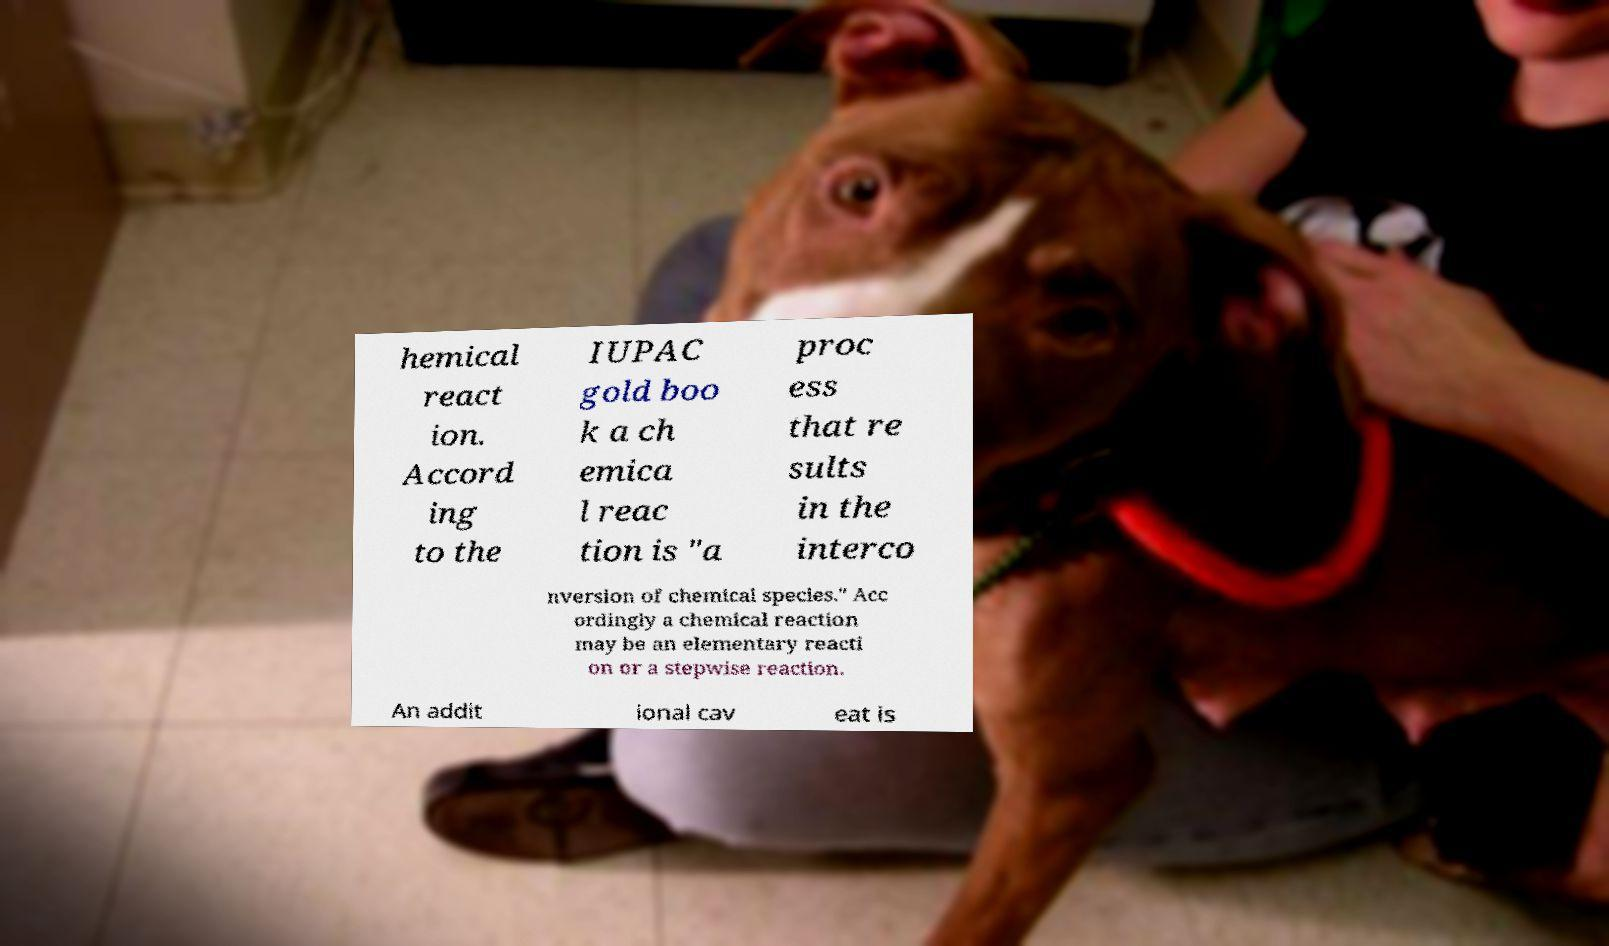Please read and relay the text visible in this image. What does it say? hemical react ion. Accord ing to the IUPAC gold boo k a ch emica l reac tion is "a proc ess that re sults in the interco nversion of chemical species." Acc ordingly a chemical reaction may be an elementary reacti on or a stepwise reaction. An addit ional cav eat is 